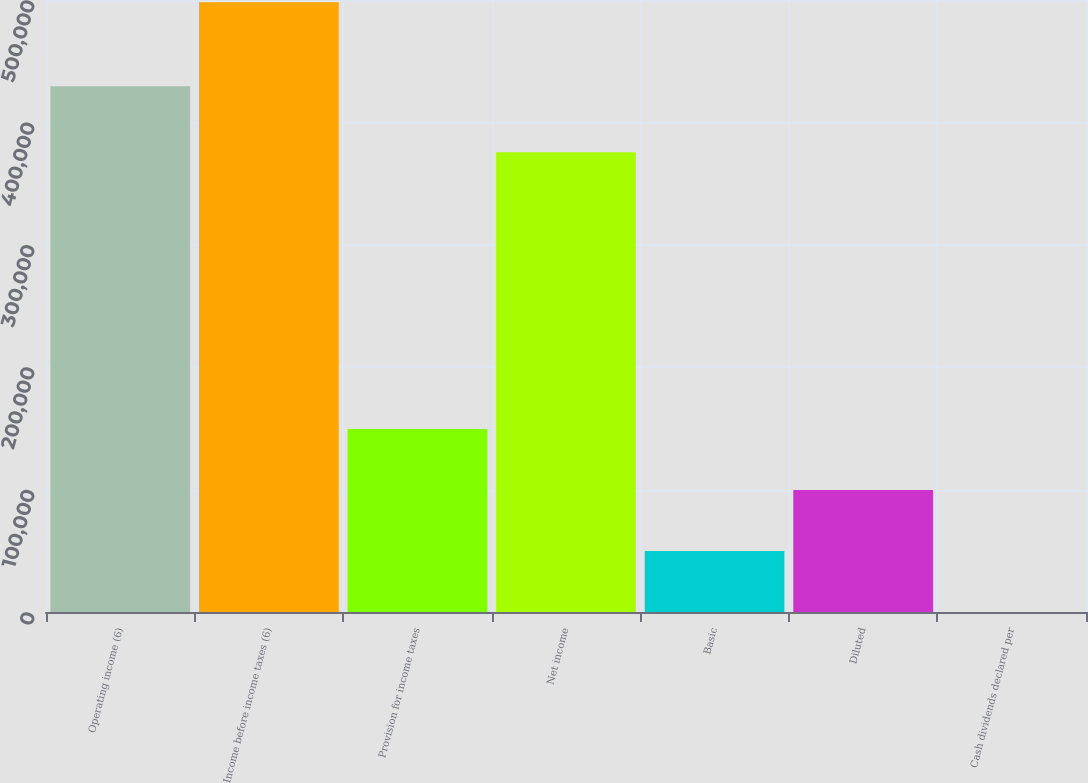Convert chart to OTSL. <chart><loc_0><loc_0><loc_500><loc_500><bar_chart><fcel>Operating income (6)<fcel>Income before income taxes (6)<fcel>Provision for income taxes<fcel>Net income<fcel>Basic<fcel>Diluted<fcel>Cash dividends declared per<nl><fcel>429518<fcel>498184<fcel>149456<fcel>375640<fcel>49818.9<fcel>99637.2<fcel>0.56<nl></chart> 